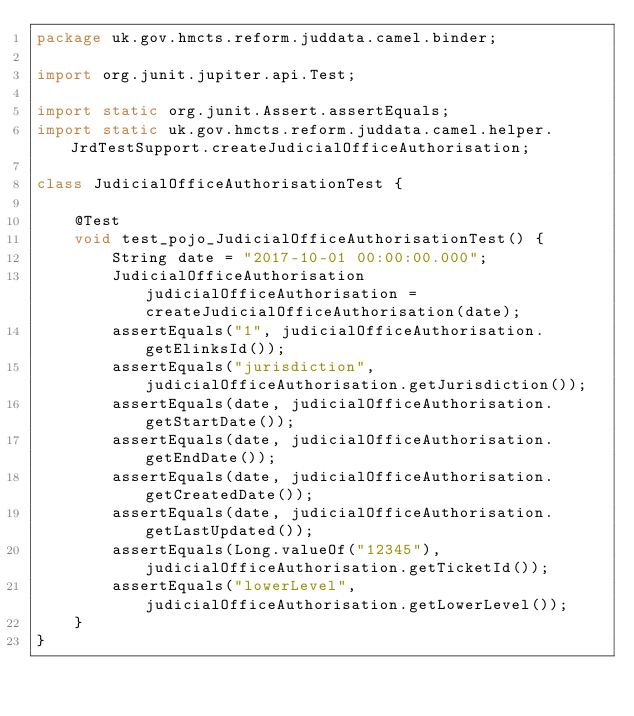<code> <loc_0><loc_0><loc_500><loc_500><_Java_>package uk.gov.hmcts.reform.juddata.camel.binder;

import org.junit.jupiter.api.Test;

import static org.junit.Assert.assertEquals;
import static uk.gov.hmcts.reform.juddata.camel.helper.JrdTestSupport.createJudicialOfficeAuthorisation;

class JudicialOfficeAuthorisationTest {

    @Test
    void test_pojo_JudicialOfficeAuthorisationTest() {
        String date = "2017-10-01 00:00:00.000";
        JudicialOfficeAuthorisation judicialOfficeAuthorisation = createJudicialOfficeAuthorisation(date);
        assertEquals("1", judicialOfficeAuthorisation.getElinksId());
        assertEquals("jurisdiction", judicialOfficeAuthorisation.getJurisdiction());
        assertEquals(date, judicialOfficeAuthorisation.getStartDate());
        assertEquals(date, judicialOfficeAuthorisation.getEndDate());
        assertEquals(date, judicialOfficeAuthorisation.getCreatedDate());
        assertEquals(date, judicialOfficeAuthorisation.getLastUpdated());
        assertEquals(Long.valueOf("12345"), judicialOfficeAuthorisation.getTicketId());
        assertEquals("lowerLevel", judicialOfficeAuthorisation.getLowerLevel());
    }
}
</code> 